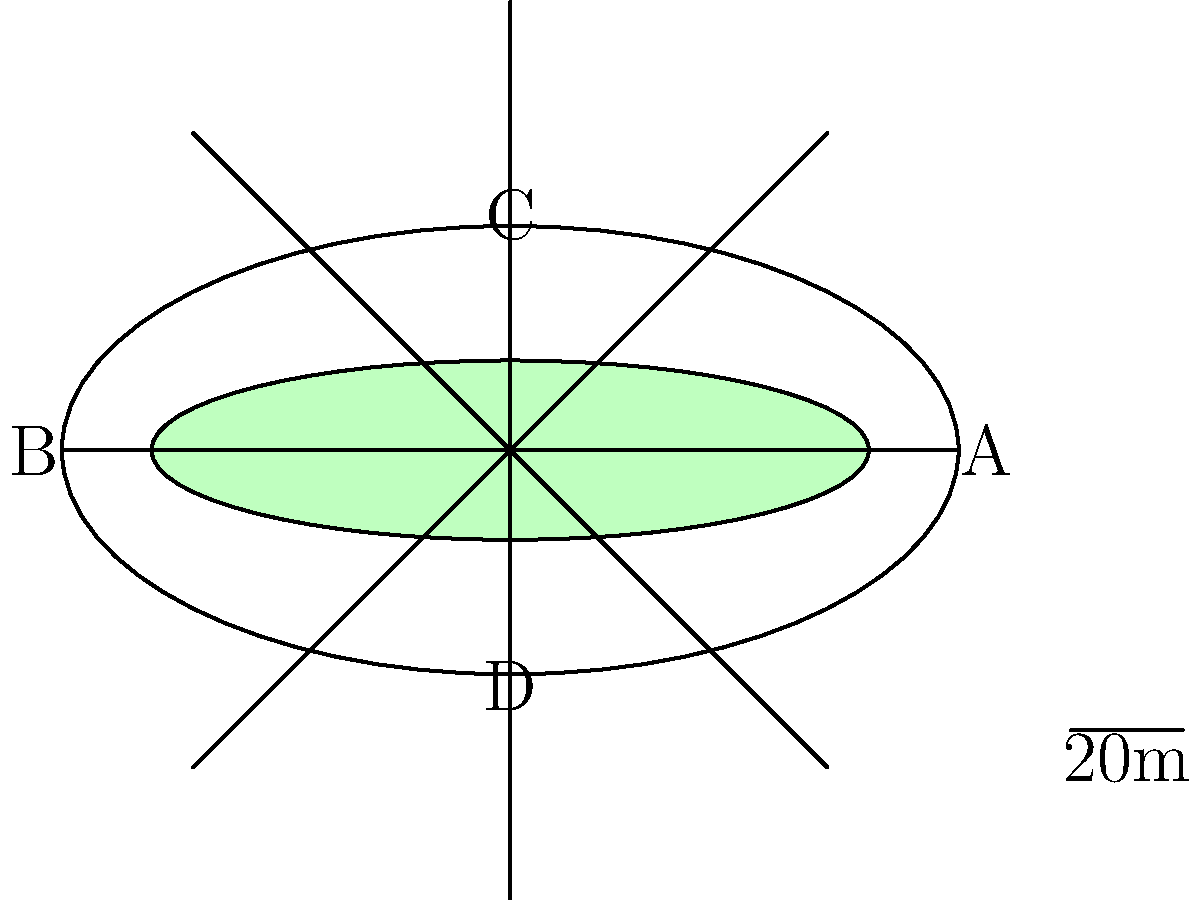As the PR director of a major football team, you're tasked with estimating the seating capacity of a new stadium from an aerial view diagram. The stadium has an elliptical shape with 8 equal sections. Given that the longest diameter (A to B) is 160 meters and the shortest diameter (C to D) is 80 meters, estimate the total seating capacity. Assume an average of 2.5 seats per square meter in the seating area. To estimate the seating capacity, we'll follow these steps:

1) Calculate the area of the entire stadium:
   Area of an ellipse = $\pi \times a \times b$, where $a$ and $b$ are the semi-major and semi-minor axes.
   $a = 160/2 = 80$ meters, $b = 80/2 = 40$ meters
   Area = $\pi \times 80 \times 40 = 10053.1$ sq meters

2) Calculate the area of the field:
   The field appears to be 80% of the length and 40% of the width of the stadium.
   Field dimensions: $128$ m $\times 32$ m
   Field area = $128 \times 32 = 4096$ sq meters

3) Calculate the seating area:
   Seating area = Total area - Field area
   $10053.1 - 4096 = 5957.1$ sq meters

4) Estimate the number of seats:
   Given: 2.5 seats per square meter
   Number of seats = Seating area $\times$ 2.5
   $5957.1 \times 2.5 = 14892.75$

5) Round to a reasonable number for capacity:
   Estimated seating capacity ≈ 15,000

This estimation provides a ballpark figure based on the given information and assumptions.
Answer: Approximately 15,000 seats 